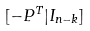<formula> <loc_0><loc_0><loc_500><loc_500>[ - P ^ { T } | I _ { n - k } ]</formula> 